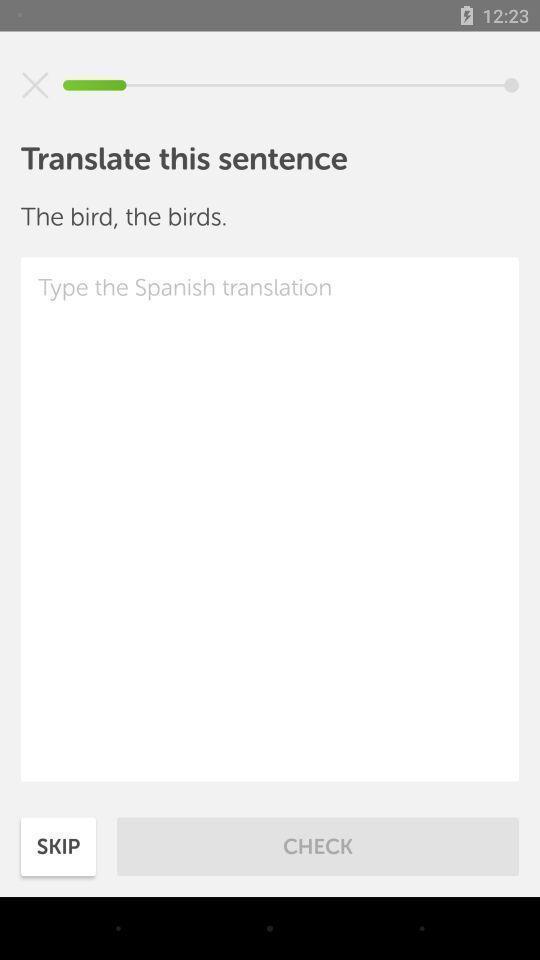Provide a description of this screenshot. Screen page of language translator app. 